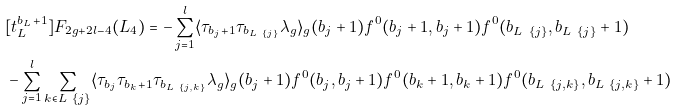Convert formula to latex. <formula><loc_0><loc_0><loc_500><loc_500>& [ t _ { L } ^ { b _ { L } + 1 } ] F _ { 2 g + 2 l - 4 } ( L _ { 4 } ) = - \sum _ { j = 1 } ^ { l } \langle \tau _ { b _ { j } + 1 } \tau _ { b _ { L \ \{ j \} } } \lambda _ { g } \rangle _ { g } ( b _ { j } + 1 ) f ^ { 0 } ( b _ { j } + 1 , b _ { j } + 1 ) f ^ { 0 } ( b _ { L \ \{ j \} } , b _ { L \ \{ j \} } + 1 ) \\ & - \sum _ { j = 1 } ^ { l } \sum _ { k \in L \ \{ j \} } \langle \tau _ { b _ { j } } \tau _ { b _ { k } + 1 } \tau _ { b _ { L \ \{ j , k \} } } \lambda _ { g } \rangle _ { g } ( b _ { j } + 1 ) f ^ { 0 } ( b _ { j } , b _ { j } + 1 ) f ^ { 0 } ( b _ { k } + 1 , b _ { k } + 1 ) f ^ { 0 } ( b _ { L \ \{ j , k \} } , b _ { L \ \{ j , k \} } + 1 )</formula> 